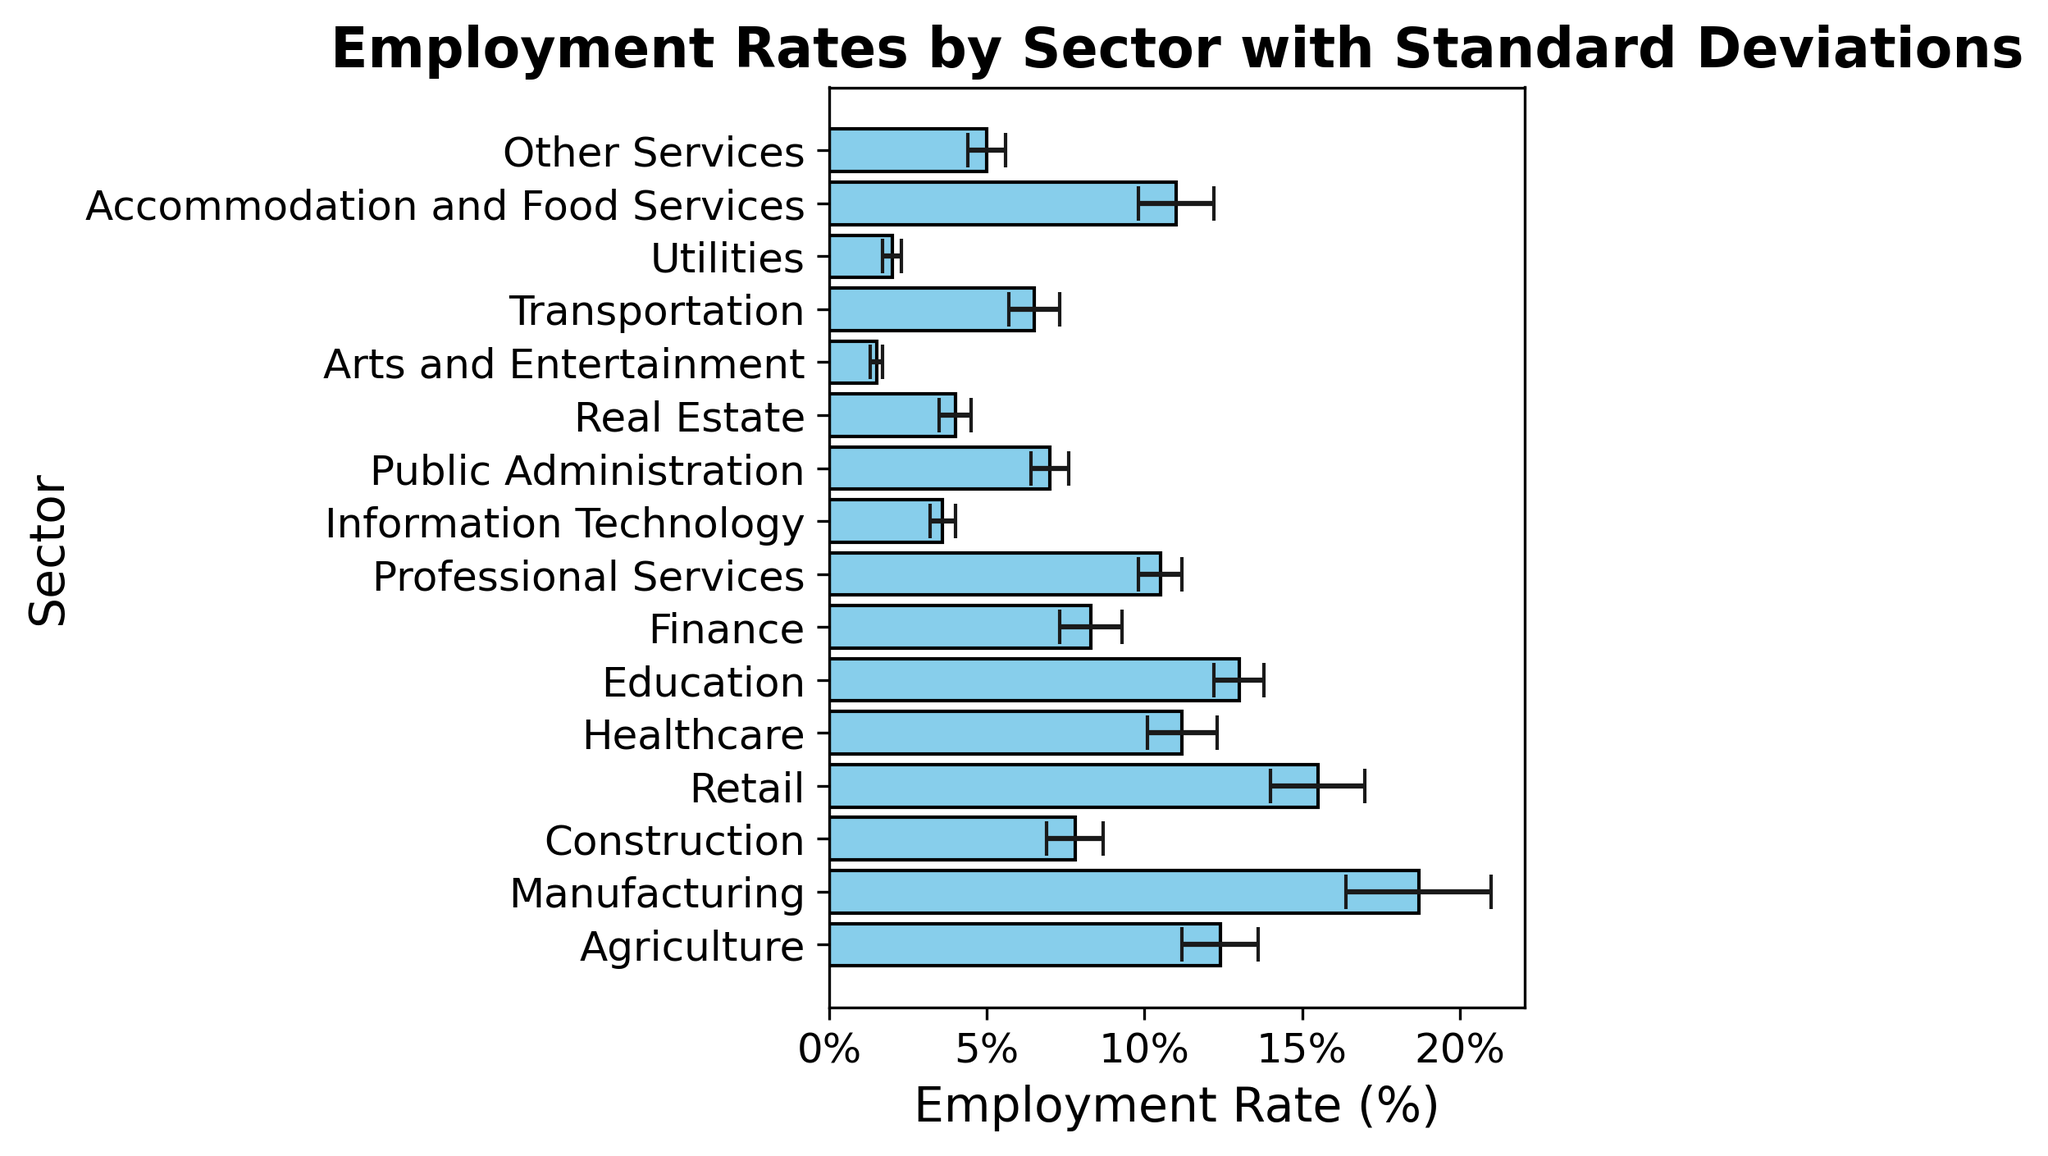Which sector has the highest employment rate? The highest bar indicates the sector with the highest employment rate. The bar for Manufacturing is the tallest, representing the highest employment rate.
Answer: Manufacturing Which sector has the lowest employment rate? The shortest bar indicates the sector with the lowest employment rate. The bar for Arts and Entertainment is the shortest, representing the lowest employment rate.
Answer: Arts and Entertainment How does the employment rate in Retail compare to that in Healthcare? By visually comparing the heights of the bars for Retail and Healthcare, we see that Retail has a higher employment rate than Healthcare.
Answer: Retail is higher What is the employment rate difference between Public Administration and Construction? The heights of the bars for Public Administration and Construction are 7.0% and 7.8%, respectively. The difference is calculated as 7.8% - 7.0% = 0.8%.
Answer: 0.8% Which sector has a similar employment rate to Finance? By visually inspecting the bars, we see that the Professional Services sector has an employment rate close to 8.3%, similar to Finance.
Answer: Professional Services What is the combined employment rate of Agriculture and Education? The heights of the bars for Agriculture and Education are 12.4% and 13.0%, respectively. The sum is 12.4% + 13.0% = 25.4%.
Answer: 25.4% Compare the standard deviations of Construction and Transportation. Which is higher? The standard deviations for Construction and Transportation are 0.9% and 0.8%, respectively. Since 0.9% > 0.8%, Construction has a higher standard deviation.
Answer: Construction What is the average employment rate of the top three sectors by employment rate? The top three sectors by employment rate are Manufacturing (18.7%), Retail (15.5%), and Education (13.0%). The average is calculated as (18.7% + 15.5% + 13.0%)/3 ≈ 15.73%.
Answer: 15.73% What is the median employment rate among all sectors? To find the median, we list the employment rates and find the middle value. The sorted rates are: 1.5%, 2.0%, 3.6%, 4.0%, 5.0%, 6.5%, 7.0%, 7.8%, 8.3%, 10.5%, 11.0%, 11.2%, 12.4%, 13.0%, 15.5%, 18.7%. The median is the middle value (8th and 9th values) averaged: (7.8% + 8.3%)/2 = 8.05%.
Answer: 8.05% What is the sum of the employment rates in sectors related to services (Healthcare, Education, Professional Services, Accommodation and Food Services, Other Services)? The employment rates for these sectors are 11.2%, 13.0%, 10.5%, 11.0%, 5.0%. The sum is 11.2% + 13.0% + 10.5% + 11.0% + 5.0% = 50.7%.
Answer: 50.7% 